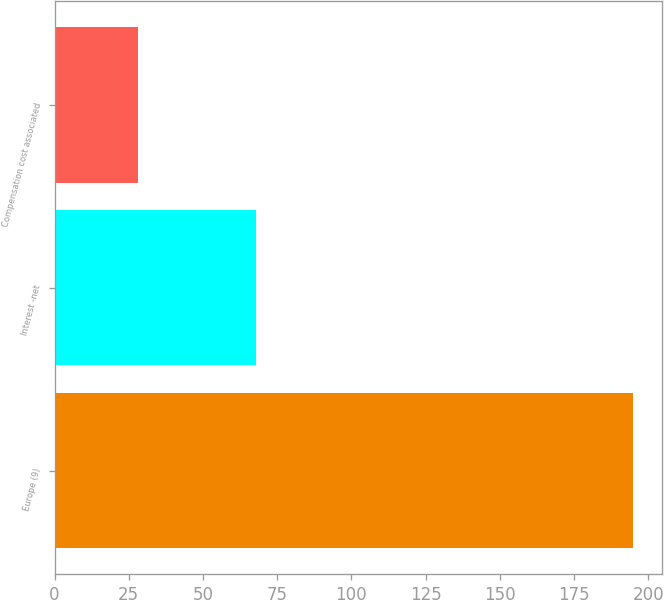Convert chart. <chart><loc_0><loc_0><loc_500><loc_500><bar_chart><fcel>Europe (9)<fcel>Interest -net<fcel>Compensation cost associated<nl><fcel>195<fcel>68<fcel>28<nl></chart> 